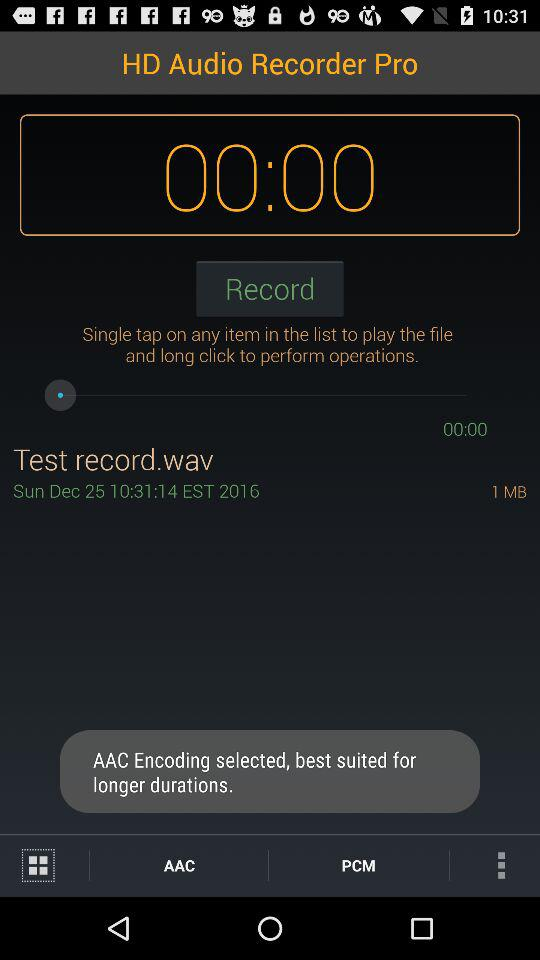How much storage is used by the recording?
Answer the question using a single word or phrase. 1 MB 